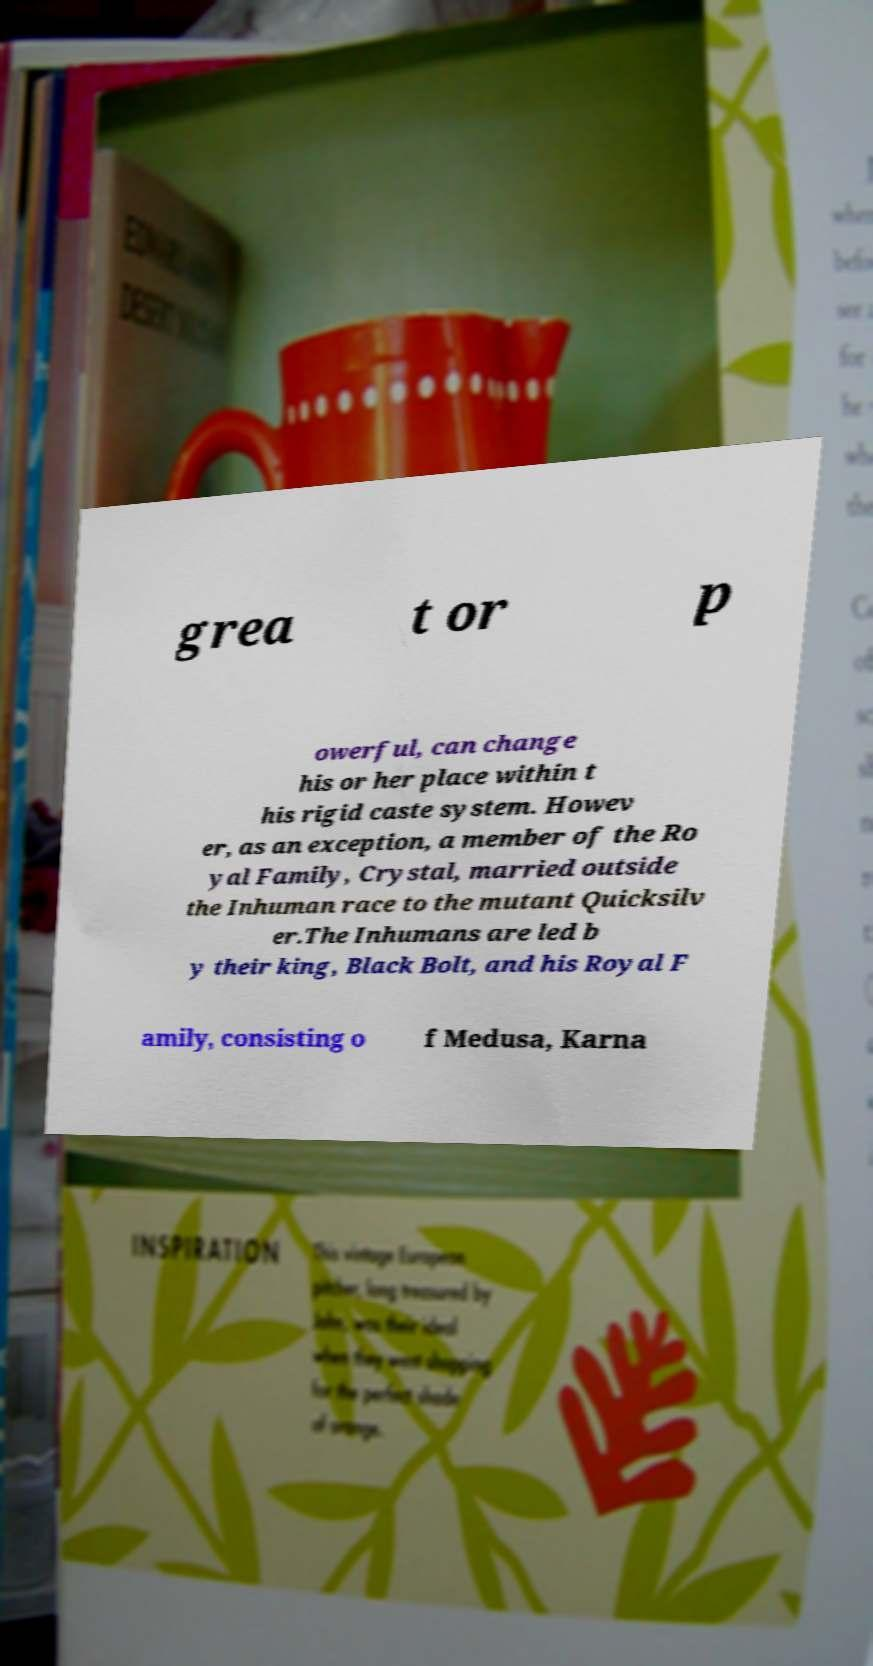Please identify and transcribe the text found in this image. grea t or p owerful, can change his or her place within t his rigid caste system. Howev er, as an exception, a member of the Ro yal Family, Crystal, married outside the Inhuman race to the mutant Quicksilv er.The Inhumans are led b y their king, Black Bolt, and his Royal F amily, consisting o f Medusa, Karna 